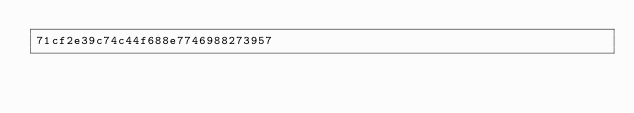Convert code to text. <code><loc_0><loc_0><loc_500><loc_500><_SML_>71cf2e39c74c44f688e7746988273957</code> 